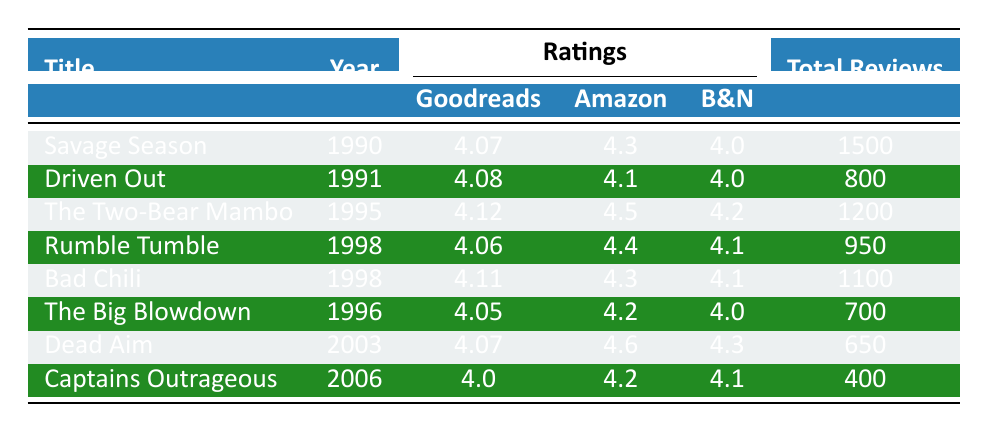What is the Goodreads rating for "Bad Chili"? The table shows that the Goodreads rating for "Bad Chili," published in 1998, is 4.11.
Answer: 4.11 How many total reviews are there for "The Two-Bear Mambo"? According to the table, "The Two-Bear Mambo" has a total of 1200 reviews.
Answer: 1200 Which book has the highest Amazon rating? By comparing the ratings column, "Dead Aim" has the highest Amazon rating of 4.6.
Answer: 4.6 What is the average Goodreads rating across all listed books? The Goodreads ratings are 4.07, 4.08, 4.12, 4.06, 4.11, 4.05, 4.07, and 4.0. Their sum is 32.56, and there are 8 books: 32.56/8 = 4.07.
Answer: 4.07 How many negative reviews does "Driven Out" have? The table indicates that "Driven Out" has 200 negative reviews.
Answer: 200 True or False: "Rumble Tumble" has more positive reviews than "Savage Season." "Rumble Tumble" has 700 positive reviews while "Savage Season" has 1200. Thus, this statement is false.
Answer: False What is the difference in total reviews between "Captains Outrageous" and "The Big Blowdown"? "Captains Outrageous" has 400 total reviews, and "The Big Blowdown" has 700 total reviews. The difference is 700 - 400 = 300.
Answer: 300 Which book was published most recently and what is its Goodreads rating? The most recent book in the table is "Captains Outrageous," published in 2006, and its Goodreads rating is 4.0.
Answer: 4.0 How many more positive reviews does "Bad Chili" have compared to "Dead Aim"? "Bad Chili" has 900 positive reviews and "Dead Aim" has 500, so 900 - 500 = 400 more positive reviews.
Answer: 400 Is the average Amazon rating higher than the average Barnes and Noble rating? The Amazon ratings are 4.3, 4.1, 4.5, 4.4, 4.3, 4.2, 4.6, and 4.2 with an average of 4.32. The B&N ratings are 4.0, 4.0, 4.2, 4.1, 4.1, 4.0, 4.3, and 4.1 with an average of 4.1. Since 4.32 > 4.1, the answer is yes.
Answer: Yes 